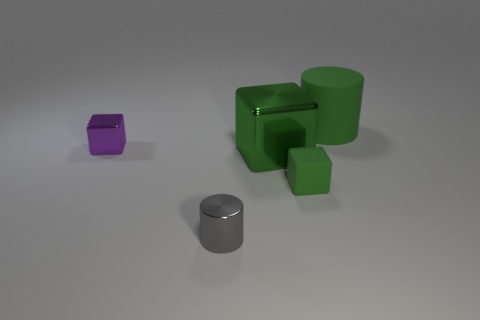Add 4 small purple matte cubes. How many objects exist? 9 Subtract all cylinders. How many objects are left? 3 Subtract all green cubes. Subtract all tiny gray metal things. How many objects are left? 2 Add 4 shiny cylinders. How many shiny cylinders are left? 5 Add 1 small blue metal blocks. How many small blue metal blocks exist? 1 Subtract 0 red blocks. How many objects are left? 5 